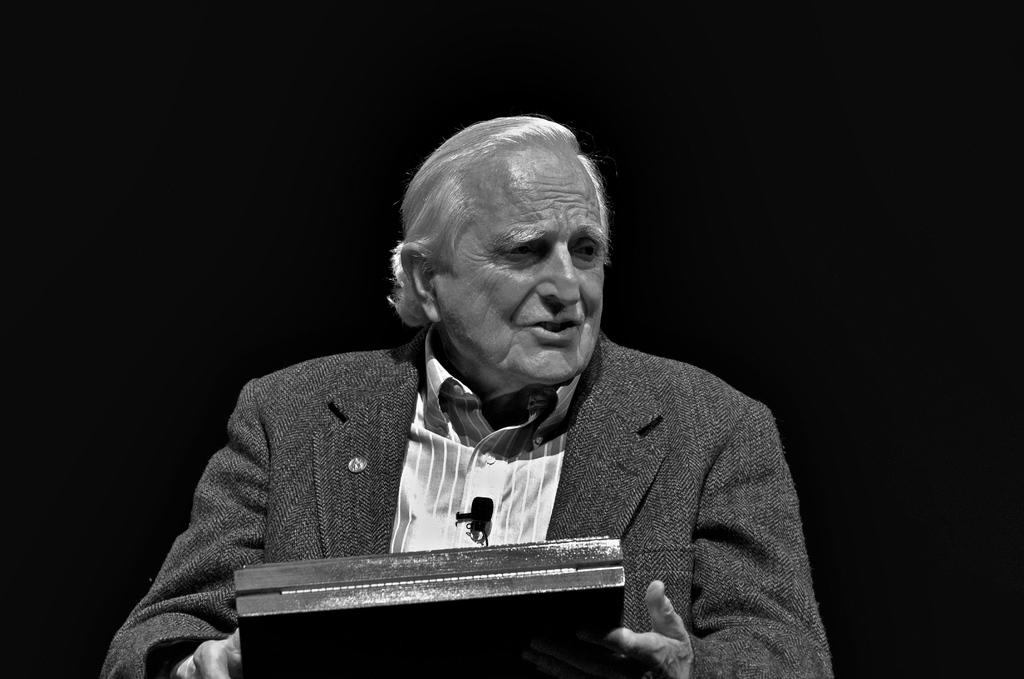What is the color scheme of the image? The image is black and white. Who is present in the image? There is a man in the image. What is the man doing in the image? The man is holding an object. What can be seen in the background of the image? The background of the image is black. What type of pencil is the man using to draw in the image? There is no pencil present in the image, and the man is not drawing. 